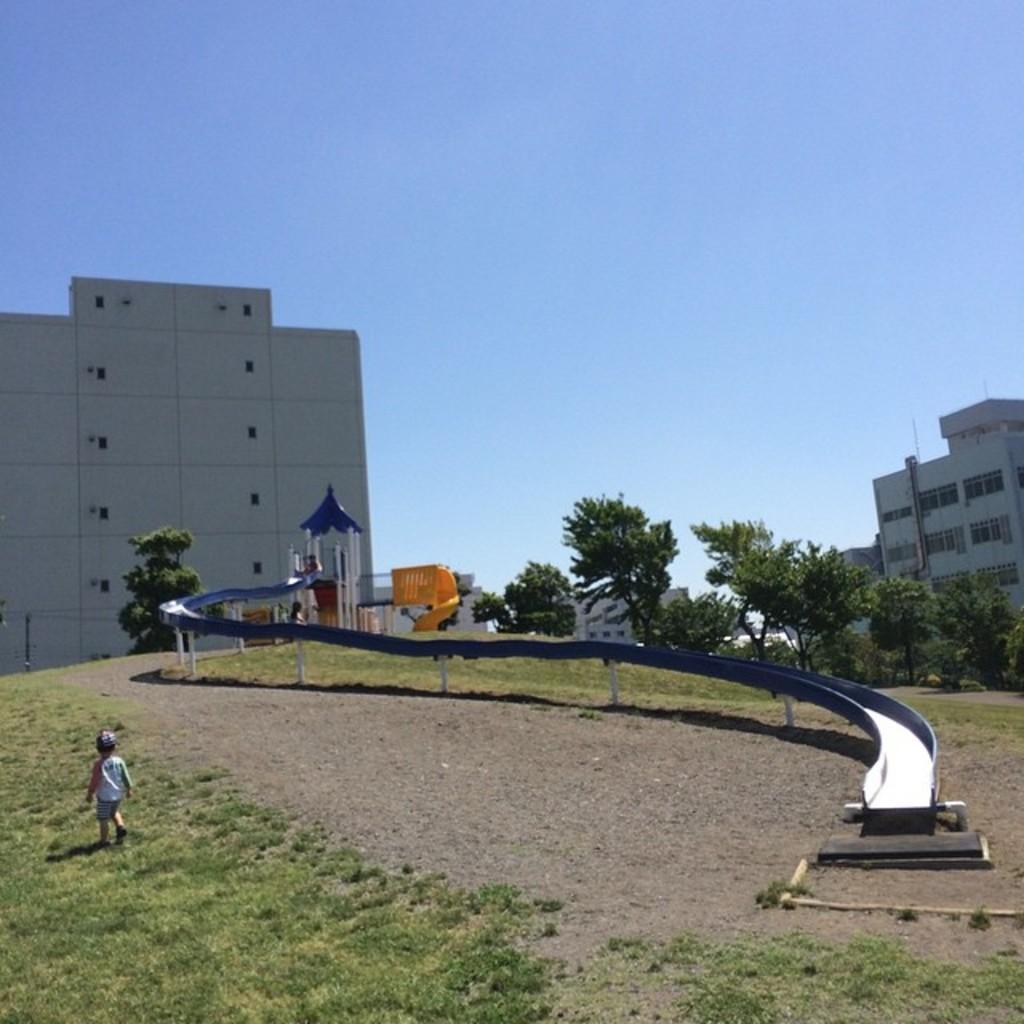Can you describe this image briefly? In this image in the center there is slide, and in the background there are buildings and trees. And at the bottom there is grass and walkway, and on the left side there is one boy. At the top there is sky. 